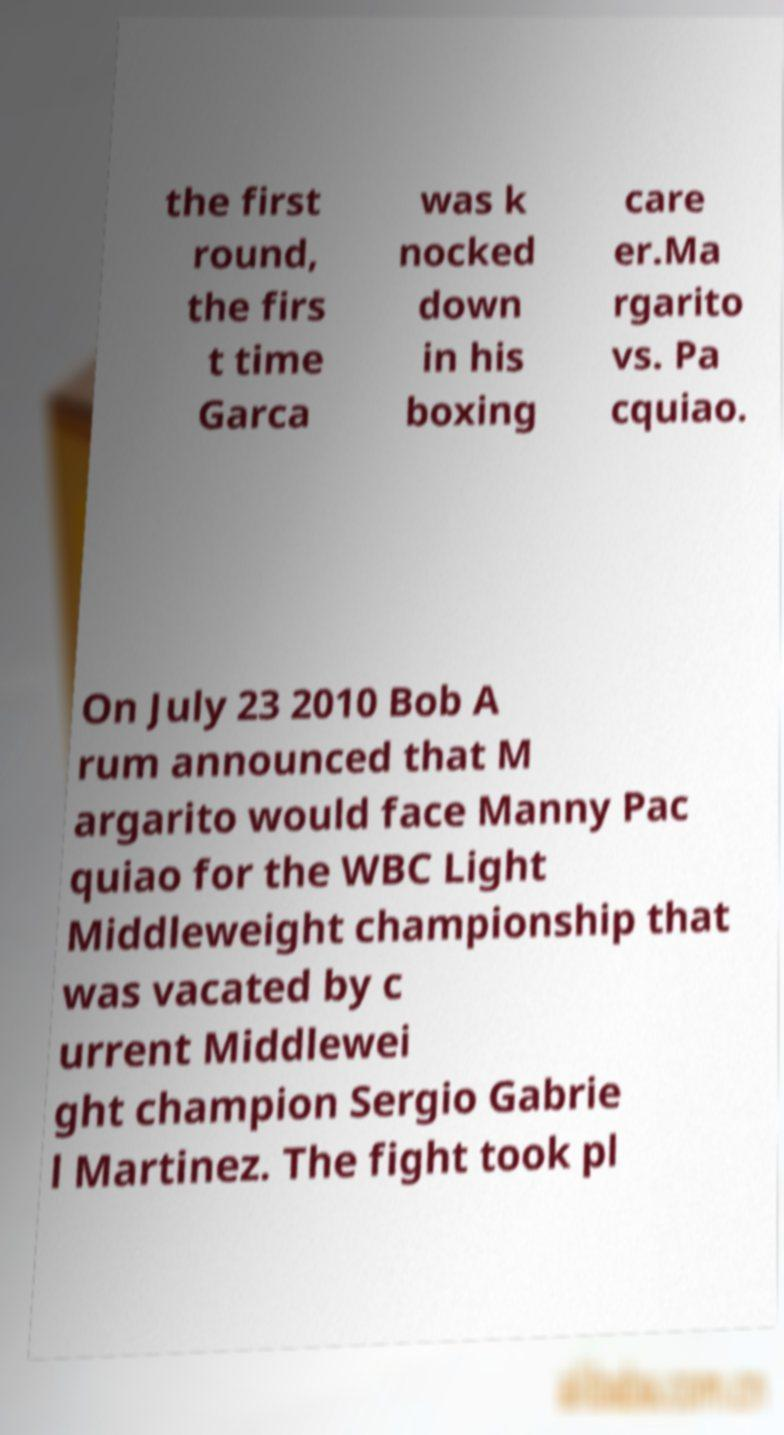There's text embedded in this image that I need extracted. Can you transcribe it verbatim? the first round, the firs t time Garca was k nocked down in his boxing care er.Ma rgarito vs. Pa cquiao. On July 23 2010 Bob A rum announced that M argarito would face Manny Pac quiao for the WBC Light Middleweight championship that was vacated by c urrent Middlewei ght champion Sergio Gabrie l Martinez. The fight took pl 